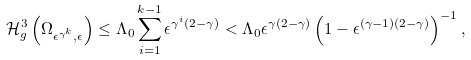Convert formula to latex. <formula><loc_0><loc_0><loc_500><loc_500>\mathcal { H } ^ { 3 } _ { g } \left ( \Omega _ { \epsilon ^ { \gamma ^ { k } } , \epsilon } \right ) \leq \Lambda _ { 0 } \sum _ { i = 1 } ^ { k - 1 } \epsilon ^ { \gamma ^ { i } ( 2 - \gamma ) } < \Lambda _ { 0 } \epsilon ^ { \gamma ( 2 - \gamma ) } \left ( 1 - \epsilon ^ { ( \gamma - 1 ) ( 2 - \gamma ) } \right ) ^ { - 1 } ,</formula> 